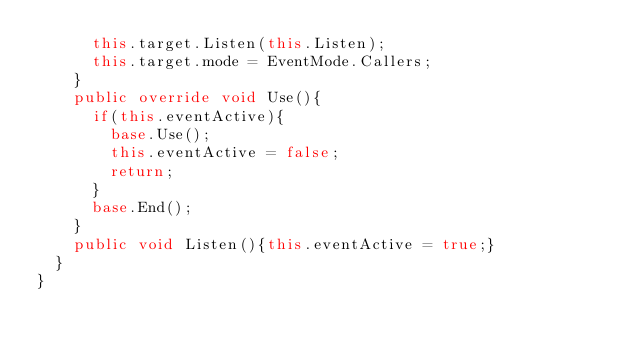<code> <loc_0><loc_0><loc_500><loc_500><_C#_>			this.target.Listen(this.Listen);
			this.target.mode = EventMode.Callers;
		}
		public override void Use(){
			if(this.eventActive){
				base.Use();
				this.eventActive = false;
				return;
			}
			base.End();
		}
		public void Listen(){this.eventActive = true;}
	}
}</code> 